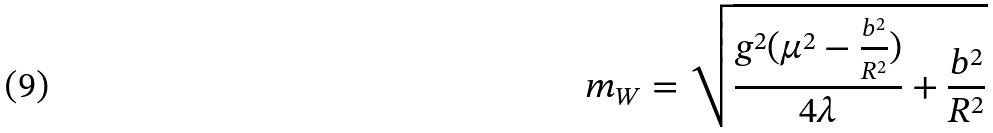Convert formula to latex. <formula><loc_0><loc_0><loc_500><loc_500>m _ { W } = \sqrt { \frac { g ^ { 2 } ( \mu ^ { 2 } - \frac { b ^ { 2 } } { R ^ { 2 } } ) } { 4 \lambda } + \frac { b ^ { 2 } } { R ^ { 2 } } }</formula> 